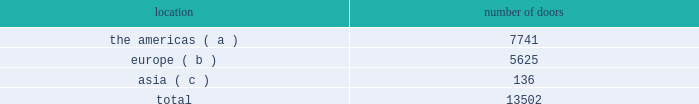Worldwide wholesale distribution channels the table presents the number of doors by geographic location in which products distributed by our wholesale segment were sold to consumers in our primary channels of distribution as of april 2 , 2016: .
( a ) includes the u.s. , canada , and latin america .
( b ) includes the middle east .
( c ) includes australia and new zealand .
We have three key wholesale customers that generate significant sales volume .
During fiscal 2016 , sales to our largest wholesale customer , macy's , inc .
( "macy's" ) , accounted for approximately 11% ( 11 % ) and 25% ( 25 % ) of our total net revenues and total wholesale net revenues , respectively .
Further , during fiscal 2016 , sales to our three largest wholesale customers , including macy's , accounted for approximately 24% ( 24 % ) and 53% ( 53 % ) of our total net revenues and total wholesale net revenues , respectively .
Our products are sold primarily by our own sales forces .
Our wholesale segment maintains its primary showrooms in new york city .
In addition , we maintain regional showrooms in milan , paris , london , munich , madrid , stockholm , and panama .
Shop-within-shops .
As a critical element of our distribution to department stores , we and our licensing partners utilize shop-within-shops to enhance brand recognition , to permit more complete merchandising of our lines by the department stores , and to differentiate the presentation of our products .
As of april 2 , 2016 , we had approximately 25000 shop-within-shops in our primary channels of distribution dedicated to our wholesale products worldwide .
The size of our shop-within-shops ranges from approximately 100 to 9200 square feet .
Shop-within-shop fixed assets primarily include items such as customized freestanding fixtures , wall cases and components , decorative items , and flooring .
We normally share in the cost of building out these shop-within-shops with our wholesale customers .
Basic stock replenishment program .
Basic products such as knit shirts , chino pants , oxford cloth shirts , select accessories , and home products can be ordered by our wholesale customers at any time through our basic stock replenishment program .
We generally ship these products within two to five days of order receipt .
Our retail segment our retail segment sells directly to customers throughout the world via our 493 retail stores , totaling approximately 3.8 million square feet , and 583 concession-based shop-within-shops , as well as through our various e-commerce sites .
The extension of our direct-to-consumer reach is one of our primary long-term strategic goals .
We operate our retail business using an omni-channel retailing strategy that seeks to deliver an integrated shopping experience with a consistent message of our brands and products to our customers , regardless of whether they are shopping for our products in one of our physical stores or online .
Ralph lauren stores our ralph lauren stores feature a broad range of apparel , accessories , watch and jewelry , fragrance , and home product assortments in an atmosphere reflecting the distinctive attitude and image of the ralph lauren , polo , double rl , and denim & supply brands , including exclusive merchandise that is not sold in department stores .
During fiscal 2016 , we opened 22 new ralph lauren stores and closed 21 stores .
Our ralph lauren stores are primarily situated in major upscale street locations and upscale regional malls , generally in large urban markets. .
What percentage of doors in the wholesale segment as of april 2 , 2016 where in the europe geography? 
Computations: (5625 / 13502)
Answer: 0.4166. 